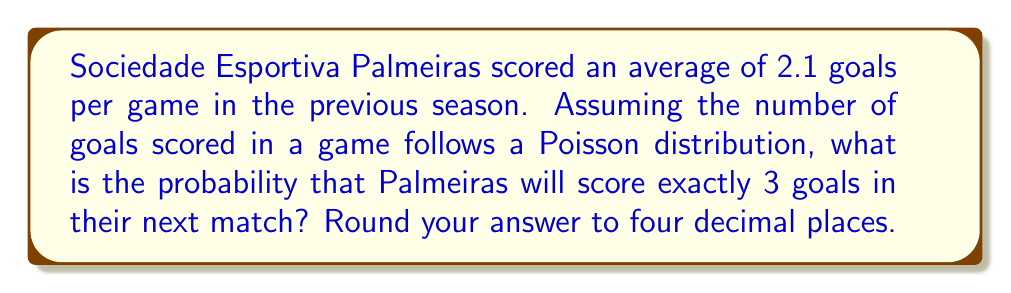Can you answer this question? To solve this problem, we'll use the Poisson distribution, which is often used to model the number of events occurring in a fixed interval of time or space. In this case, it's the number of goals scored in a single match.

The Poisson probability mass function is given by:

$$P(X = k) = \frac{e^{-\lambda} \lambda^k}{k!}$$

Where:
$\lambda$ = average number of events (goals) per interval
$k$ = number of events we're calculating the probability for
$e$ = Euler's number (approximately 2.71828)

Given:
$\lambda = 2.1$ (average goals per game)
$k = 3$ (we want the probability of scoring exactly 3 goals)

Let's substitute these values into the formula:

$$P(X = 3) = \frac{e^{-2.1} (2.1)^3}{3!}$$

Step 1: Calculate $e^{-2.1}$
$e^{-2.1} \approx 0.12246$

Step 2: Calculate $(2.1)^3$
$(2.1)^3 = 9.261$

Step 3: Calculate $3!$
$3! = 3 \times 2 \times 1 = 6$

Step 4: Put it all together
$$P(X = 3) = \frac{0.12246 \times 9.261}{6} \approx 0.1889$$

Step 5: Round to four decimal places
$0.1889$ rounded to four decimal places is $0.1889$

Therefore, the probability that Palmeiras will score exactly 3 goals in their next match is 0.1889 or about 18.89%.
Answer: 0.1889 